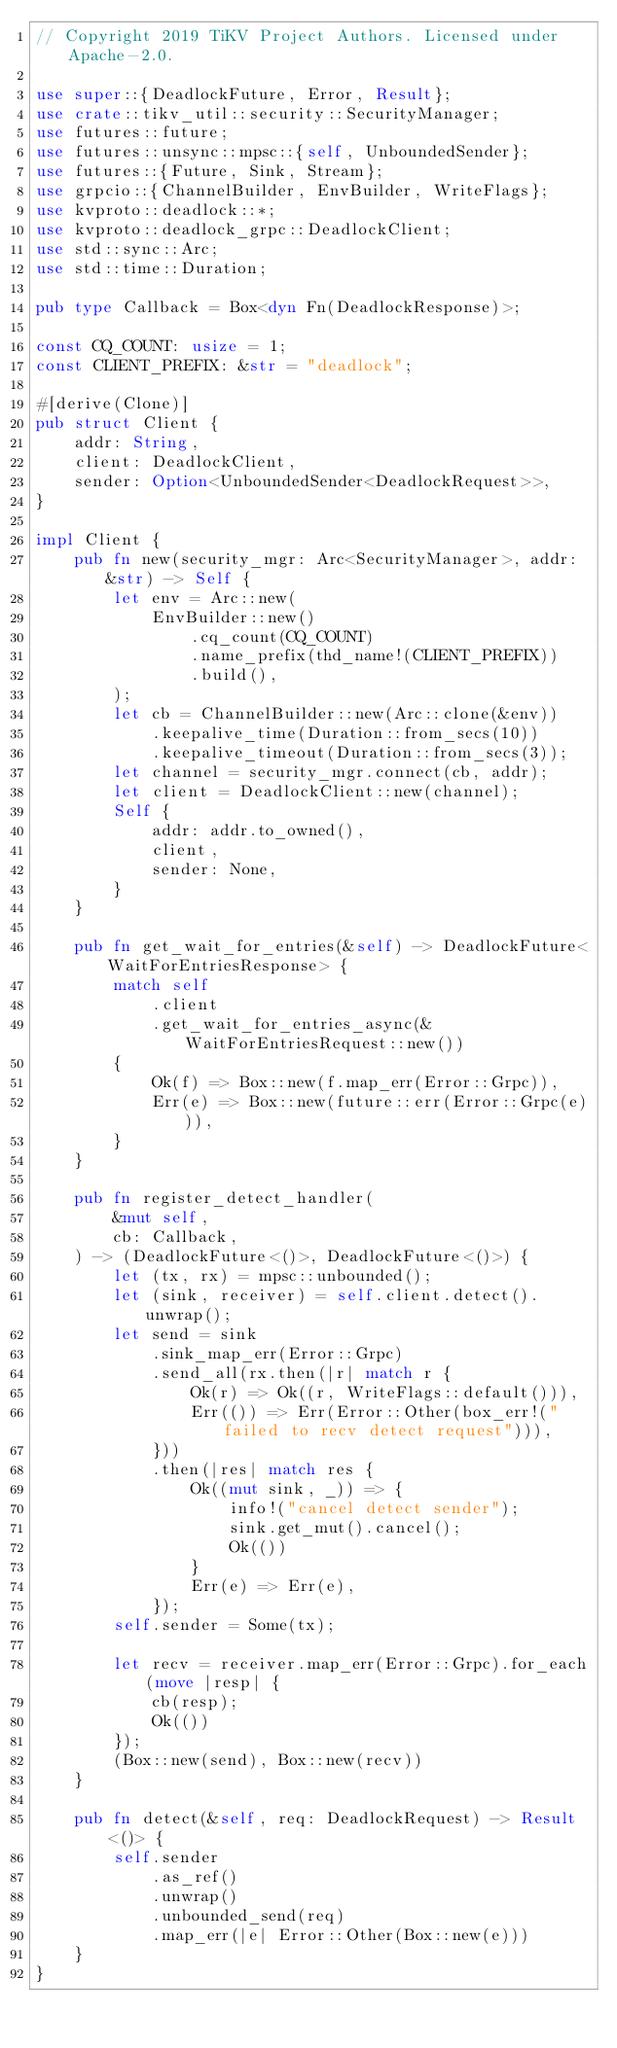Convert code to text. <code><loc_0><loc_0><loc_500><loc_500><_Rust_>// Copyright 2019 TiKV Project Authors. Licensed under Apache-2.0.

use super::{DeadlockFuture, Error, Result};
use crate::tikv_util::security::SecurityManager;
use futures::future;
use futures::unsync::mpsc::{self, UnboundedSender};
use futures::{Future, Sink, Stream};
use grpcio::{ChannelBuilder, EnvBuilder, WriteFlags};
use kvproto::deadlock::*;
use kvproto::deadlock_grpc::DeadlockClient;
use std::sync::Arc;
use std::time::Duration;

pub type Callback = Box<dyn Fn(DeadlockResponse)>;

const CQ_COUNT: usize = 1;
const CLIENT_PREFIX: &str = "deadlock";

#[derive(Clone)]
pub struct Client {
    addr: String,
    client: DeadlockClient,
    sender: Option<UnboundedSender<DeadlockRequest>>,
}

impl Client {
    pub fn new(security_mgr: Arc<SecurityManager>, addr: &str) -> Self {
        let env = Arc::new(
            EnvBuilder::new()
                .cq_count(CQ_COUNT)
                .name_prefix(thd_name!(CLIENT_PREFIX))
                .build(),
        );
        let cb = ChannelBuilder::new(Arc::clone(&env))
            .keepalive_time(Duration::from_secs(10))
            .keepalive_timeout(Duration::from_secs(3));
        let channel = security_mgr.connect(cb, addr);
        let client = DeadlockClient::new(channel);
        Self {
            addr: addr.to_owned(),
            client,
            sender: None,
        }
    }

    pub fn get_wait_for_entries(&self) -> DeadlockFuture<WaitForEntriesResponse> {
        match self
            .client
            .get_wait_for_entries_async(&WaitForEntriesRequest::new())
        {
            Ok(f) => Box::new(f.map_err(Error::Grpc)),
            Err(e) => Box::new(future::err(Error::Grpc(e))),
        }
    }

    pub fn register_detect_handler(
        &mut self,
        cb: Callback,
    ) -> (DeadlockFuture<()>, DeadlockFuture<()>) {
        let (tx, rx) = mpsc::unbounded();
        let (sink, receiver) = self.client.detect().unwrap();
        let send = sink
            .sink_map_err(Error::Grpc)
            .send_all(rx.then(|r| match r {
                Ok(r) => Ok((r, WriteFlags::default())),
                Err(()) => Err(Error::Other(box_err!("failed to recv detect request"))),
            }))
            .then(|res| match res {
                Ok((mut sink, _)) => {
                    info!("cancel detect sender");
                    sink.get_mut().cancel();
                    Ok(())
                }
                Err(e) => Err(e),
            });
        self.sender = Some(tx);

        let recv = receiver.map_err(Error::Grpc).for_each(move |resp| {
            cb(resp);
            Ok(())
        });
        (Box::new(send), Box::new(recv))
    }

    pub fn detect(&self, req: DeadlockRequest) -> Result<()> {
        self.sender
            .as_ref()
            .unwrap()
            .unbounded_send(req)
            .map_err(|e| Error::Other(Box::new(e)))
    }
}
</code> 